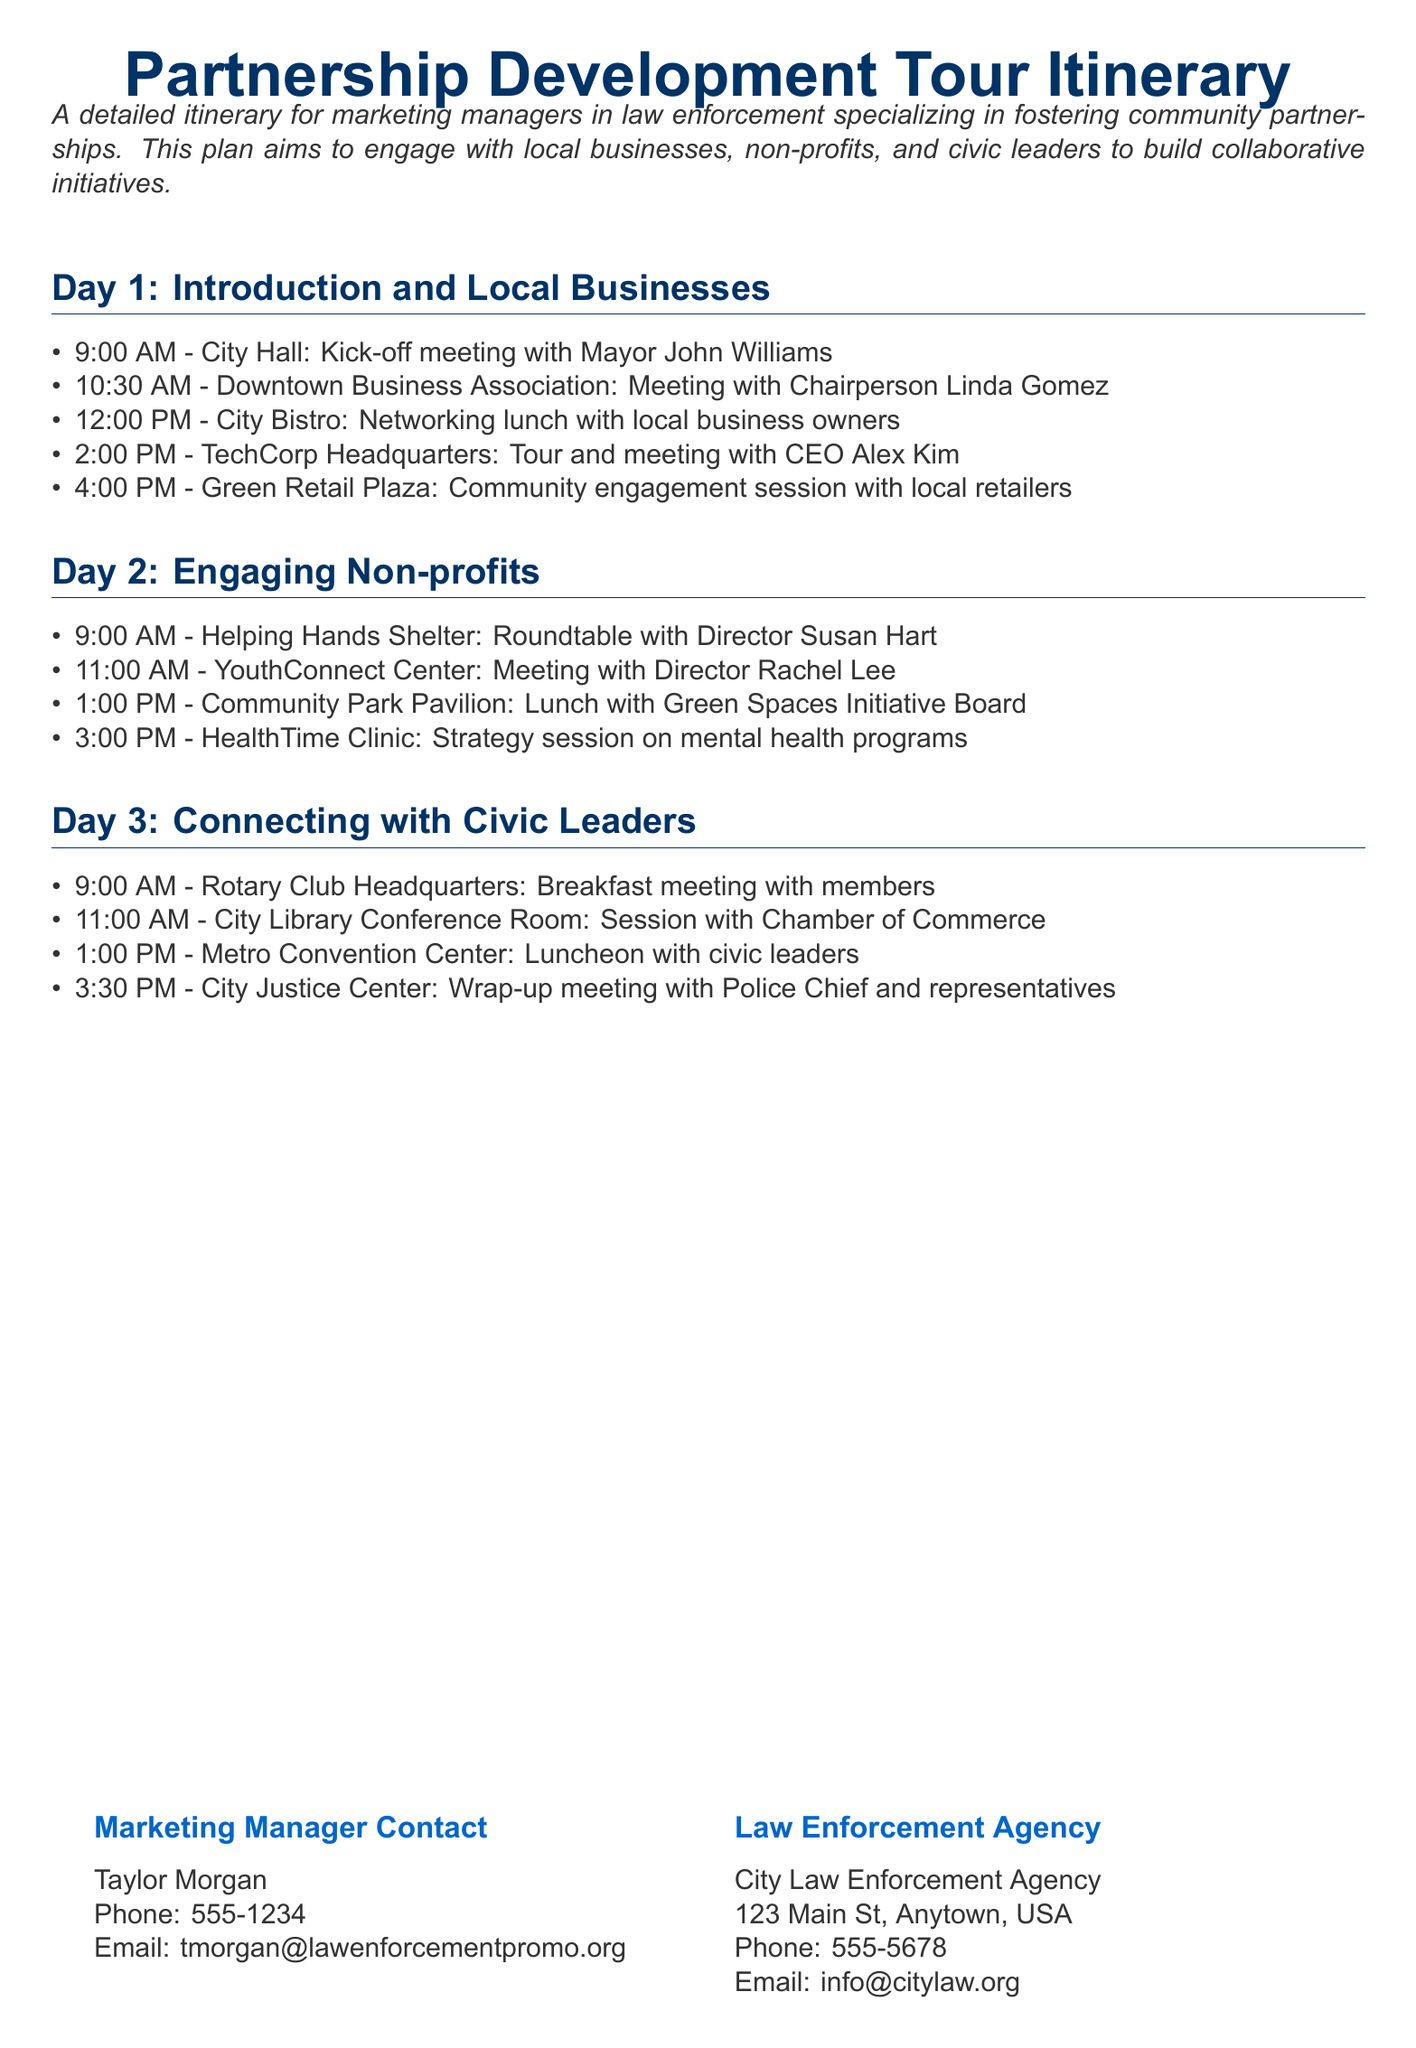What time does the kick-off meeting start? The kick-off meeting is scheduled for 9:00 AM on Day 1.
Answer: 9:00 AM Who is meeting with the Chairperson of the Downtown Business Association? The meeting with Chairperson Linda Gomez is listed on Day 1 at the Downtown Business Association.
Answer: Linda Gomez How many meetings are scheduled on Day 2? A total of four meetings are outlined on Day 2, focusing on non-profits.
Answer: Four Where is the final wrap-up meeting held? The wrap-up meeting occurs at the City Justice Center, as noted on Day 3.
Answer: City Justice Center What organization is Susan Hart associated with? Susan Hart is the Director of Helping Hands Shelter, mentioned on Day 2.
Answer: Helping Hands Shelter What type of session is scheduled at HealthTime Clinic? A strategy session on mental health programs is planned at HealthTime Clinic on Day 2.
Answer: Strategy session What aspect does the itinerary primarily focus on? The itinerary emphasizes engaging with local businesses, non-profits, and civic leaders.
Answer: Engaging community partnerships What is the contact number for Taylor Morgan? The document includes Taylor Morgan's contact number as 555-1234.
Answer: 555-1234 Which venue hosts the luncheon with civic leaders? The luncheon with civic leaders is held at the Metro Convention Center on Day 3.
Answer: Metro Convention Center 